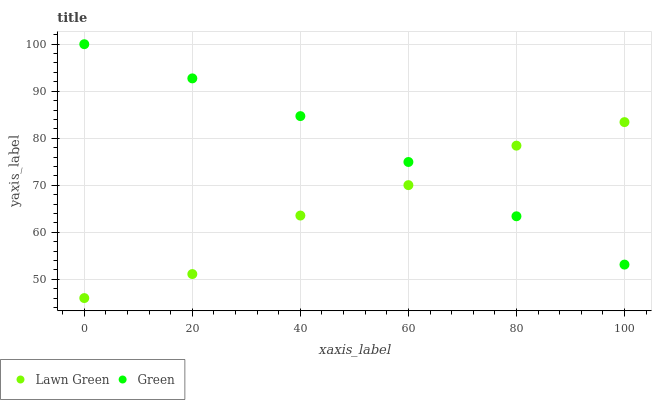Does Lawn Green have the minimum area under the curve?
Answer yes or no. Yes. Does Green have the maximum area under the curve?
Answer yes or no. Yes. Does Green have the minimum area under the curve?
Answer yes or no. No. Is Green the smoothest?
Answer yes or no. Yes. Is Lawn Green the roughest?
Answer yes or no. Yes. Is Green the roughest?
Answer yes or no. No. Does Lawn Green have the lowest value?
Answer yes or no. Yes. Does Green have the lowest value?
Answer yes or no. No. Does Green have the highest value?
Answer yes or no. Yes. Does Green intersect Lawn Green?
Answer yes or no. Yes. Is Green less than Lawn Green?
Answer yes or no. No. Is Green greater than Lawn Green?
Answer yes or no. No. 